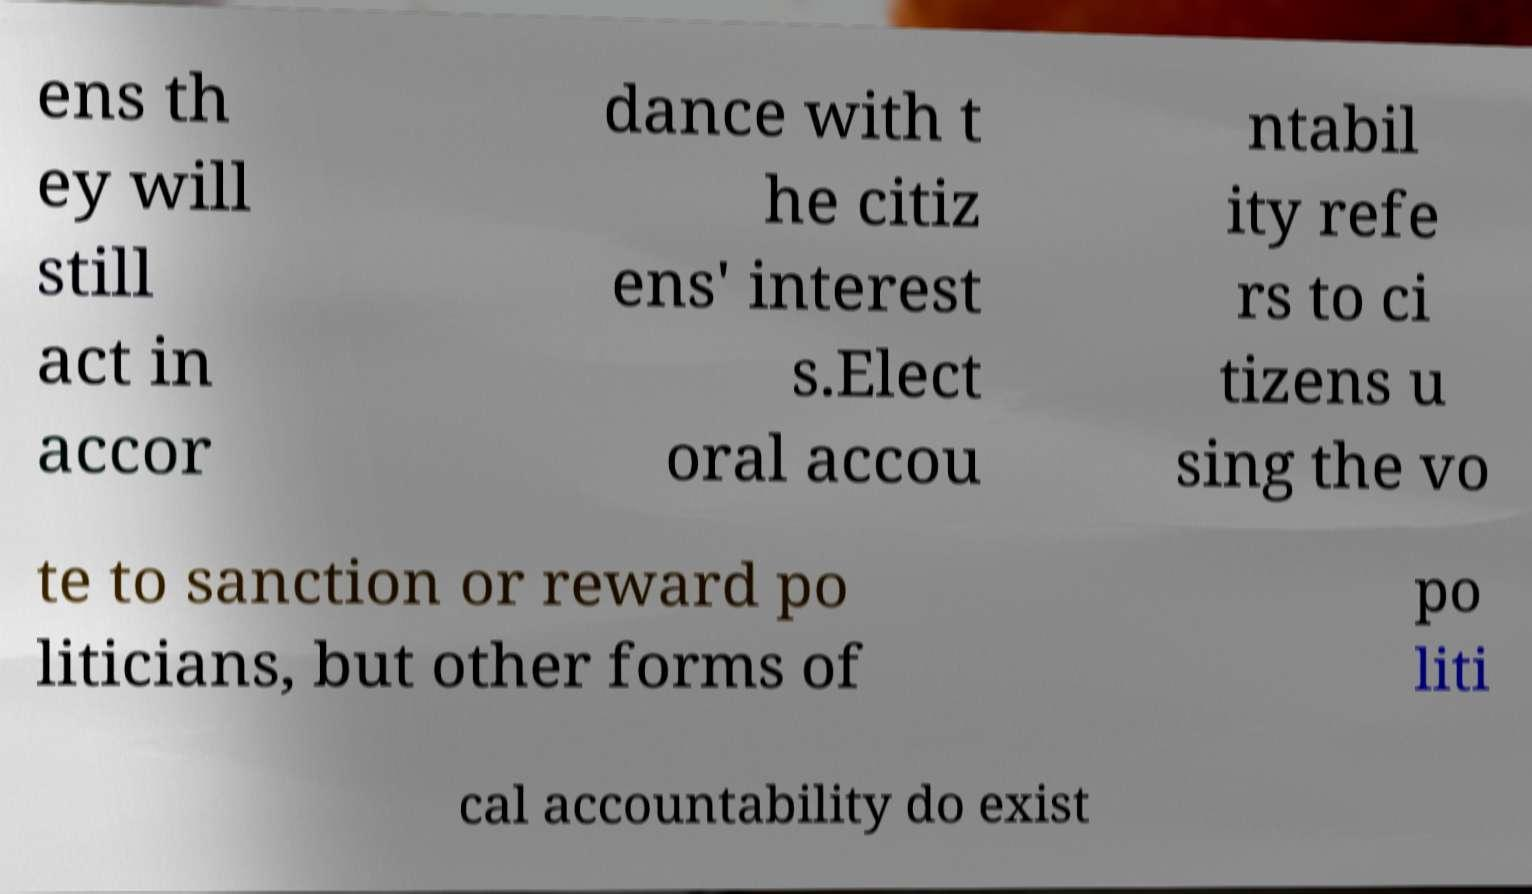For documentation purposes, I need the text within this image transcribed. Could you provide that? ens th ey will still act in accor dance with t he citiz ens' interest s.Elect oral accou ntabil ity refe rs to ci tizens u sing the vo te to sanction or reward po liticians, but other forms of po liti cal accountability do exist 